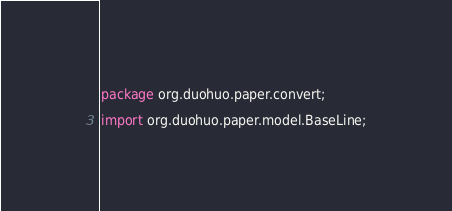Convert code to text. <code><loc_0><loc_0><loc_500><loc_500><_Java_>package org.duohuo.paper.convert;

import org.duohuo.paper.model.BaseLine;</code> 